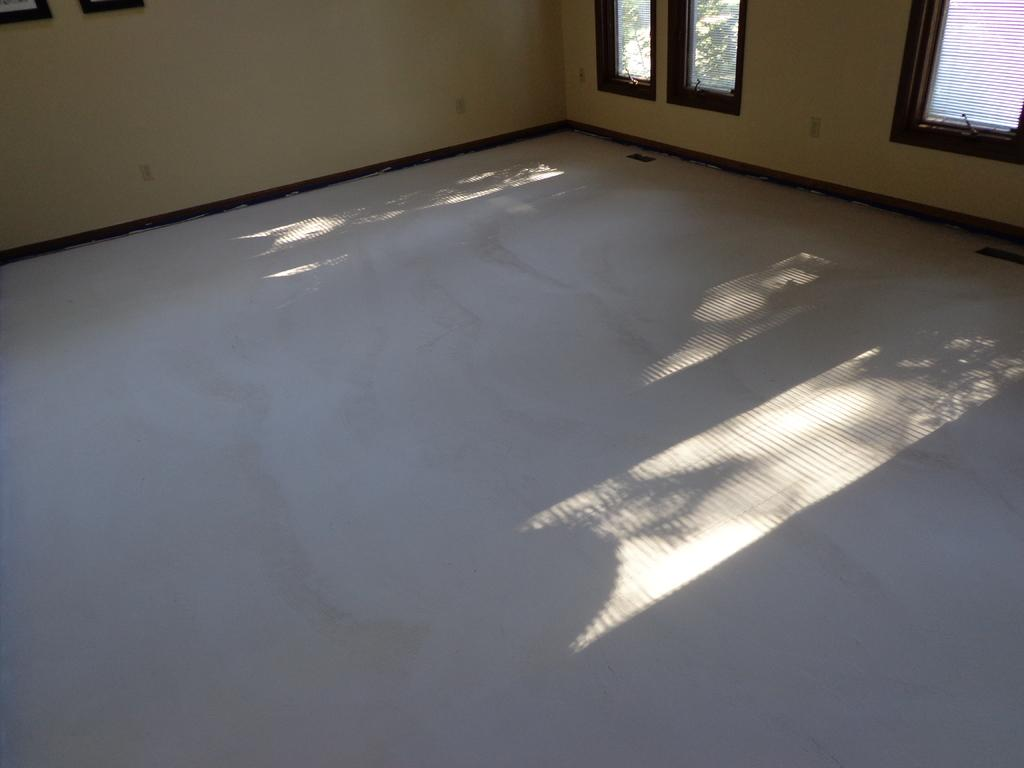What type of surface is visible at the bottom of the image? There is a floor in the image. What is located on the sides or back of the image? There is a wall in the image. What type of decorative items can be seen in the image? There are photo frames in the image. What allows natural light to enter the space in the image? There are windows in the image. What can be seen outside the windows in the image? Trees are visible through the window glass. Where is the giraffe standing in the image? There is no giraffe present in the image. What type of bag is hanging on the wall in the image? There is no bag visible in the image. 